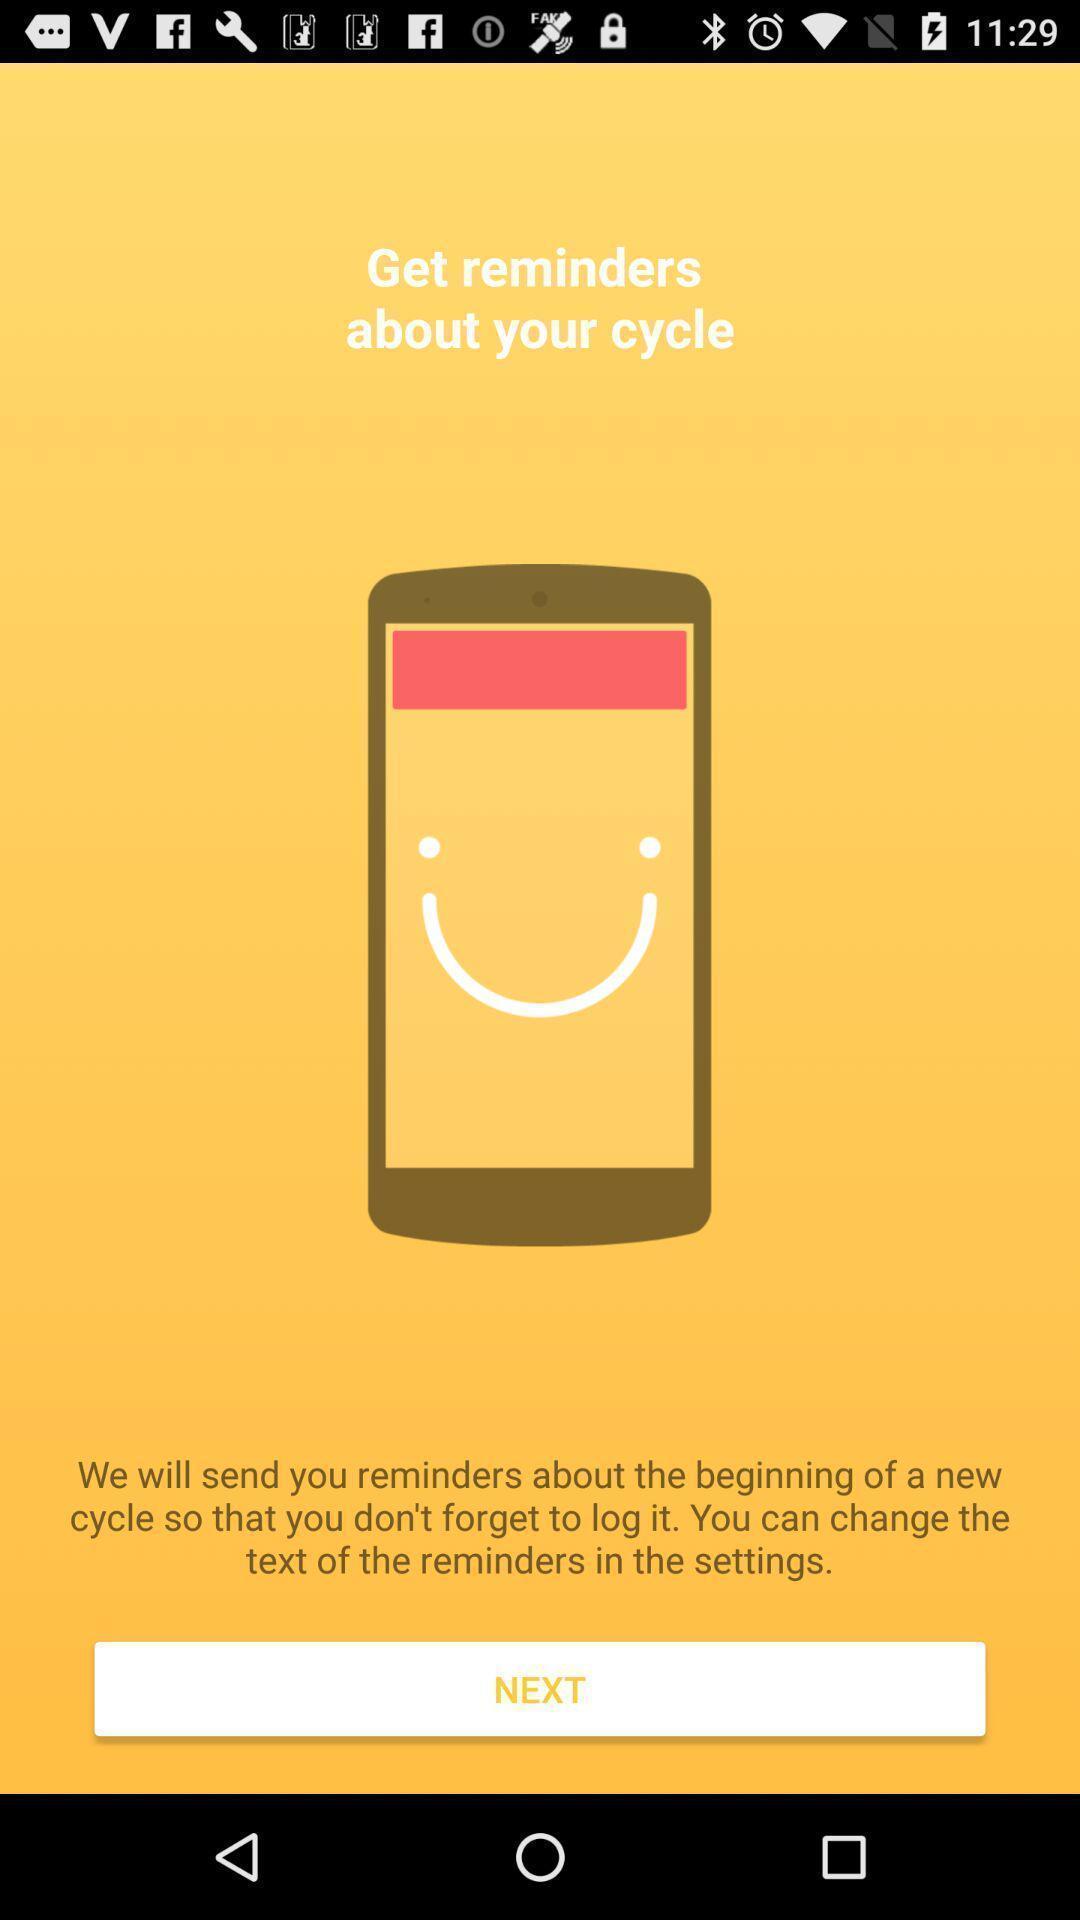Tell me about the visual elements in this screen capture. Welcome page of a reminders app. 